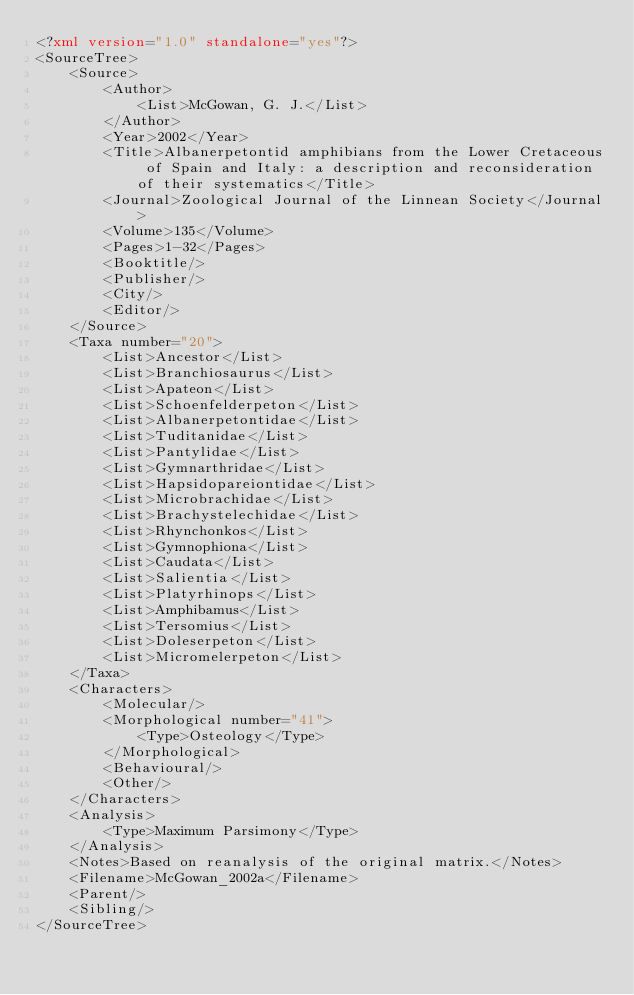<code> <loc_0><loc_0><loc_500><loc_500><_XML_><?xml version="1.0" standalone="yes"?>
<SourceTree>
	<Source>
		<Author>
			<List>McGowan, G. J.</List>
		</Author>
		<Year>2002</Year>
		<Title>Albanerpetontid amphibians from the Lower Cretaceous of Spain and Italy: a description and reconsideration of their systematics</Title>
		<Journal>Zoological Journal of the Linnean Society</Journal>
		<Volume>135</Volume>
		<Pages>1-32</Pages>
		<Booktitle/>
		<Publisher/>
		<City/>
		<Editor/>
	</Source>
	<Taxa number="20">
		<List>Ancestor</List>
		<List>Branchiosaurus</List>
		<List>Apateon</List>
		<List>Schoenfelderpeton</List>
		<List>Albanerpetontidae</List>
		<List>Tuditanidae</List>
		<List>Pantylidae</List>
		<List>Gymnarthridae</List>
		<List>Hapsidopareiontidae</List>
		<List>Microbrachidae</List>
		<List>Brachystelechidae</List>
		<List>Rhynchonkos</List>
		<List>Gymnophiona</List>
		<List>Caudata</List>
		<List>Salientia</List>
		<List>Platyrhinops</List>
		<List>Amphibamus</List>
		<List>Tersomius</List>
		<List>Doleserpeton</List>
		<List>Micromelerpeton</List>
	</Taxa>
	<Characters>
		<Molecular/>
		<Morphological number="41">
			<Type>Osteology</Type>
		</Morphological>
		<Behavioural/>
		<Other/>
	</Characters>
	<Analysis>
		<Type>Maximum Parsimony</Type>
	</Analysis>
	<Notes>Based on reanalysis of the original matrix.</Notes>
	<Filename>McGowan_2002a</Filename>
	<Parent/>
	<Sibling/>
</SourceTree>
</code> 